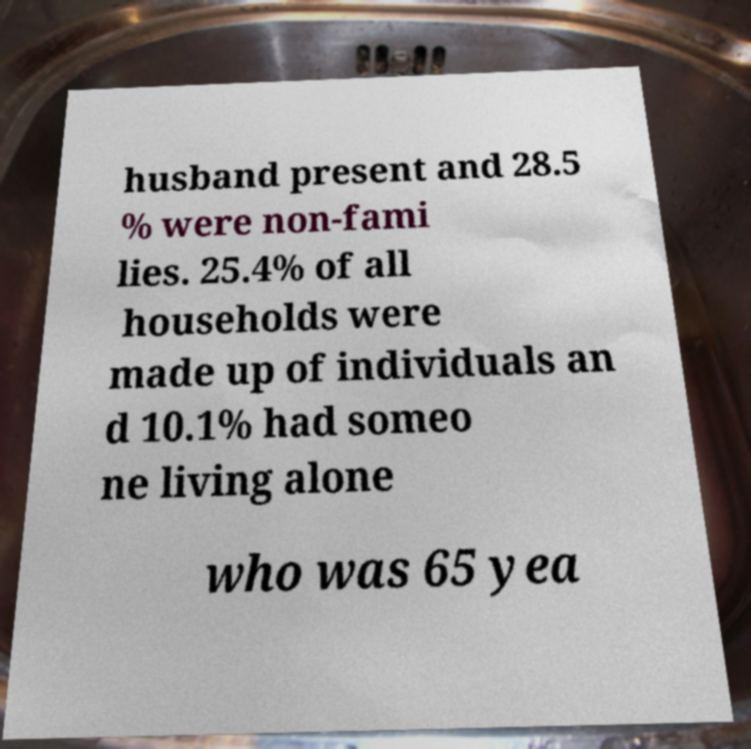There's text embedded in this image that I need extracted. Can you transcribe it verbatim? husband present and 28.5 % were non-fami lies. 25.4% of all households were made up of individuals an d 10.1% had someo ne living alone who was 65 yea 